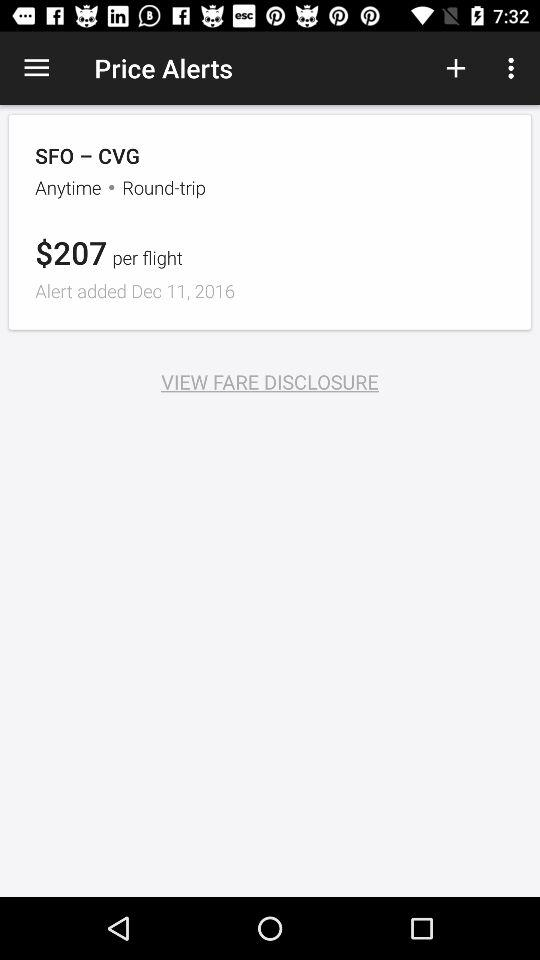What is the type of trip? The type of the trip is "Round-trip". 